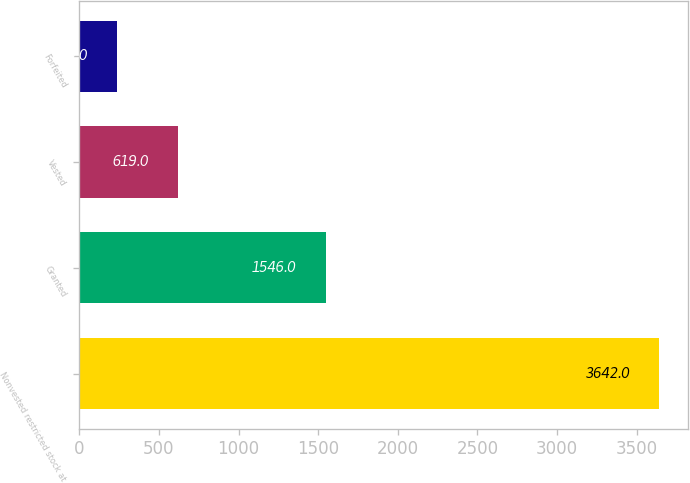Convert chart. <chart><loc_0><loc_0><loc_500><loc_500><bar_chart><fcel>Nonvested restricted stock at<fcel>Granted<fcel>Vested<fcel>Forfeited<nl><fcel>3642<fcel>1546<fcel>619<fcel>239<nl></chart> 